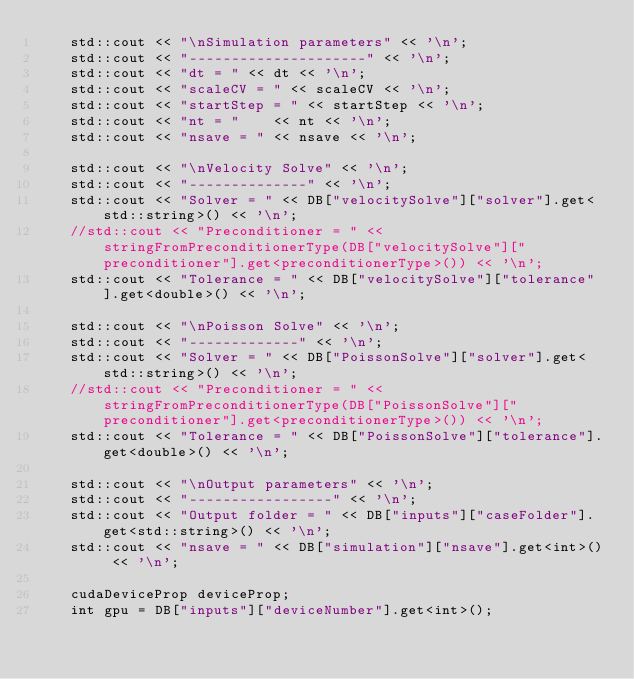<code> <loc_0><loc_0><loc_500><loc_500><_Cuda_>	std::cout << "\nSimulation parameters" << '\n';
	std::cout << "---------------------" << '\n';
	std::cout << "dt = " << dt << '\n';
	std::cout << "scaleCV = " << scaleCV << '\n';
	std::cout << "startStep = " << startStep << '\n';
	std::cout << "nt = "    << nt << '\n';
	std::cout << "nsave = " << nsave << '\n';
	
	std::cout << "\nVelocity Solve" << '\n';
	std::cout << "--------------" << '\n';
	std::cout << "Solver = " << DB["velocitySolve"]["solver"].get<std::string>() << '\n';
	//std::cout << "Preconditioner = " << stringFromPreconditionerType(DB["velocitySolve"]["preconditioner"].get<preconditionerType>()) << '\n';
	std::cout << "Tolerance = " << DB["velocitySolve"]["tolerance"].get<double>() << '\n';
	
	std::cout << "\nPoisson Solve" << '\n';
	std::cout << "-------------" << '\n';
	std::cout << "Solver = " << DB["PoissonSolve"]["solver"].get<std::string>() << '\n';
	//std::cout << "Preconditioner = " << stringFromPreconditionerType(DB["PoissonSolve"]["preconditioner"].get<preconditionerType>()) << '\n';
	std::cout << "Tolerance = " << DB["PoissonSolve"]["tolerance"].get<double>() << '\n';
	
	std::cout << "\nOutput parameters" << '\n';
	std::cout << "-----------------" << '\n';
	std::cout << "Output folder = " << DB["inputs"]["caseFolder"].get<std::string>() << '\n';
	std::cout << "nsave = " << DB["simulation"]["nsave"].get<int>() << '\n';
	
	cudaDeviceProp deviceProp;
	int gpu = DB["inputs"]["deviceNumber"].get<int>();</code> 